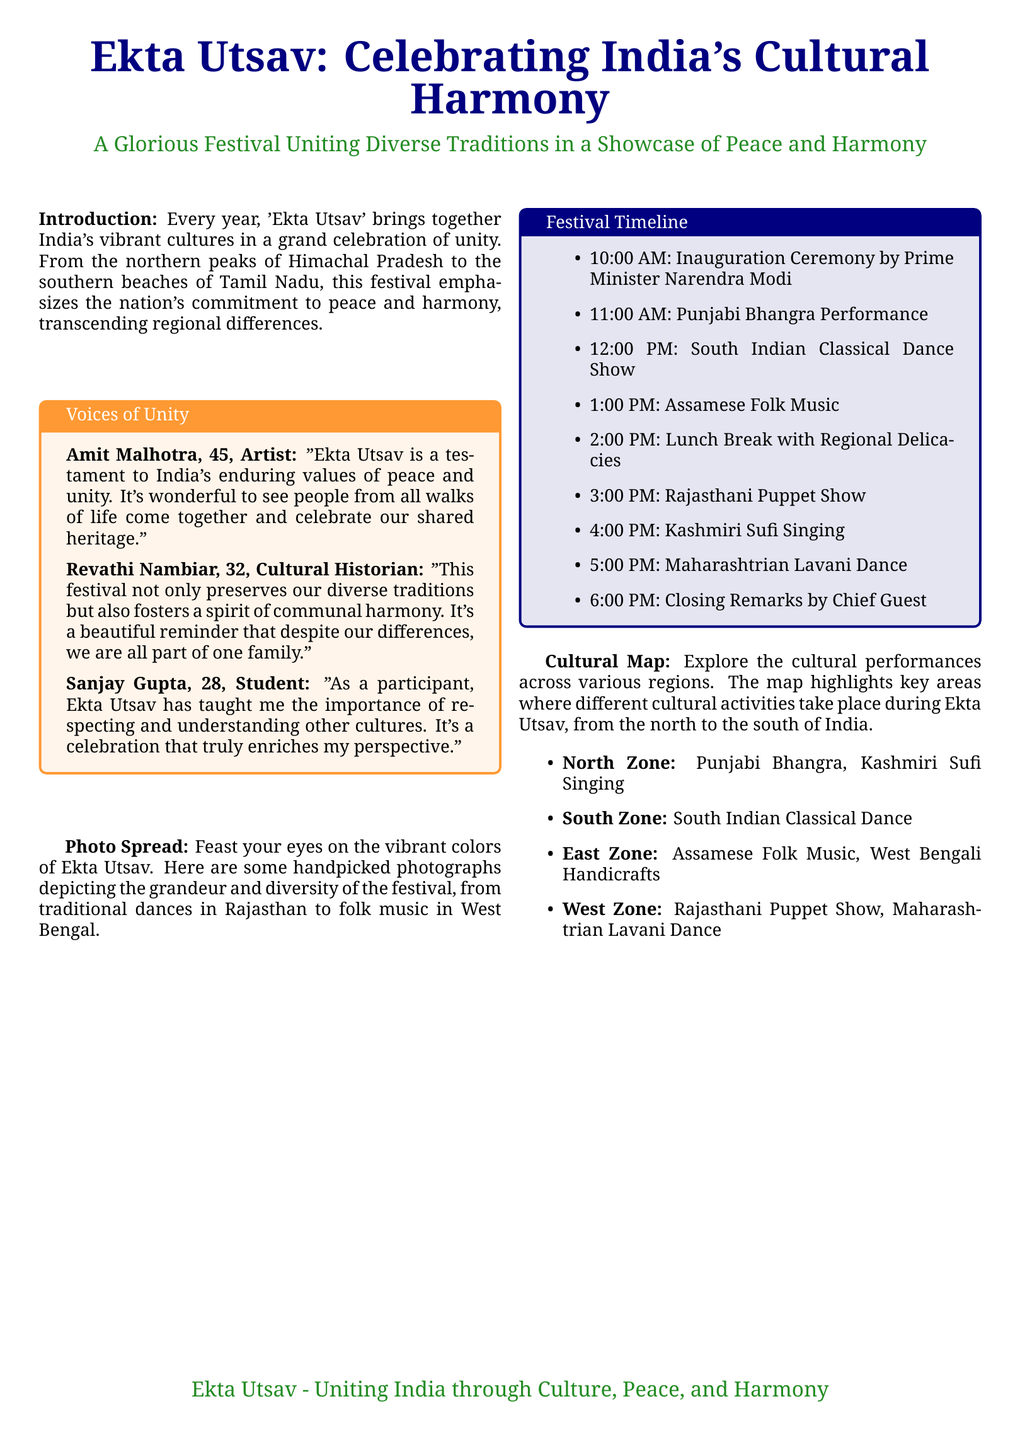What is the main theme of Ekta Utsav? The main theme of Ekta Utsav is the celebration of India's cultural harmony and unity.
Answer: Cultural harmony Who inaugurated the festival? The document states that the inauguration ceremony is conducted by Prime Minister Narendra Modi.
Answer: Prime Minister Narendra Modi What performance is scheduled at 3:00 PM? The timeline lists Rajasthani Puppet Show as the performance scheduled at this time.
Answer: Rajasthani Puppet Show Which region features Assamese Folk Music? The cultural map indicates that Assamese Folk Music is featured in the East Zone.
Answer: East Zone Who is quoted saying, "It's a beautiful reminder that despite our differences, we are all part of one family"? The quote is attributed to Revathi Nambiar, a cultural historian.
Answer: Revathi Nambiar How many performances are listed in the festival timeline? The timeline lists a total of eight performances during the festival.
Answer: Eight What color is associated with the title "Ekta Utsav"? The title "Ekta Utsav" is associated with the color navy in the document.
Answer: Navy What does Ekta Utsav emphasize according to the introduction? According to the introduction, Ekta Utsav emphasizes the nation's commitment to peace and harmony.
Answer: Peace and harmony 